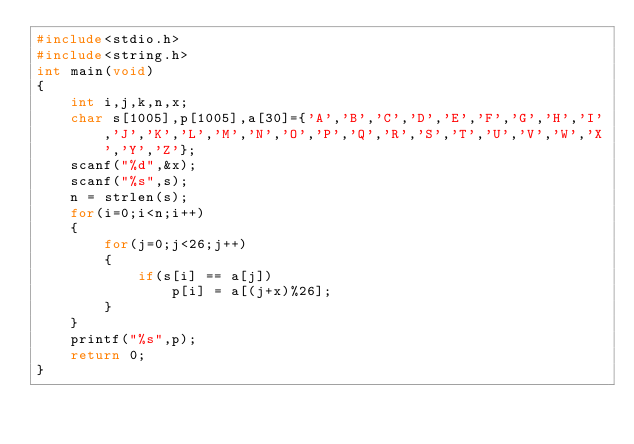Convert code to text. <code><loc_0><loc_0><loc_500><loc_500><_C_>#include<stdio.h>
#include<string.h>
int main(void)
{
    int i,j,k,n,x;
    char s[1005],p[1005],a[30]={'A','B','C','D','E','F','G','H','I','J','K','L','M','N','O','P','Q','R','S','T','U','V','W','X','Y','Z'};
    scanf("%d",&x);
    scanf("%s",s);
    n = strlen(s);
    for(i=0;i<n;i++)
    {
        for(j=0;j<26;j++)
        {
            if(s[i] == a[j])
                p[i] = a[(j+x)%26];
        }
    }
    printf("%s",p);
    return 0;
}
</code> 